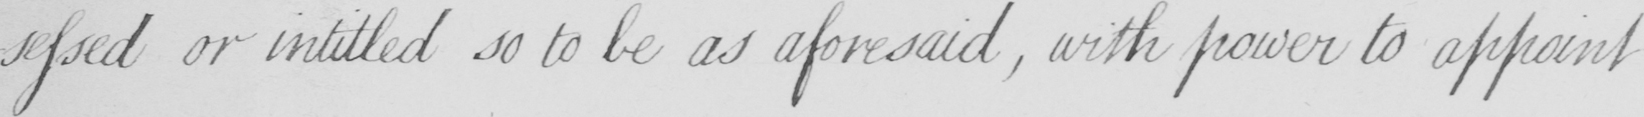Can you tell me what this handwritten text says? -ssessed or intitled so to be as aforesaid , with power to appoint 